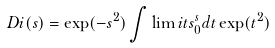Convert formula to latex. <formula><loc_0><loc_0><loc_500><loc_500>D i ( s ) = \exp ( - s ^ { 2 } ) \int \lim i t s _ { 0 } ^ { s } d t \exp ( t ^ { 2 } )</formula> 